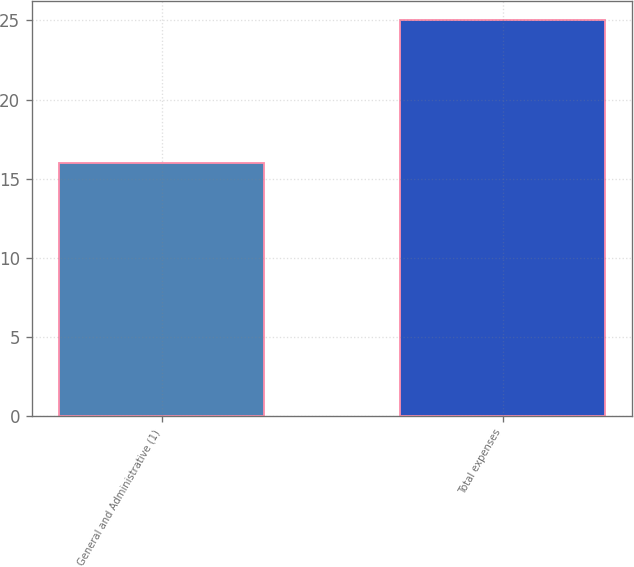Convert chart. <chart><loc_0><loc_0><loc_500><loc_500><bar_chart><fcel>General and Administrative (1)<fcel>Total expenses<nl><fcel>16<fcel>25<nl></chart> 